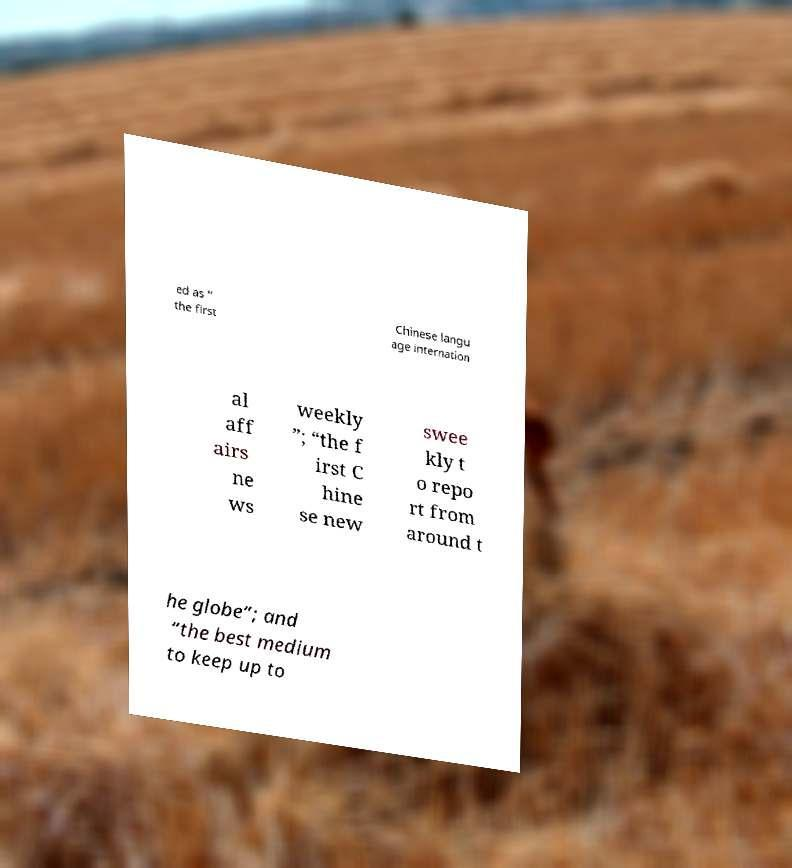For documentation purposes, I need the text within this image transcribed. Could you provide that? ed as “ the first Chinese langu age internation al aff airs ne ws weekly ”; “the f irst C hine se new swee kly t o repo rt from around t he globe”; and “the best medium to keep up to 